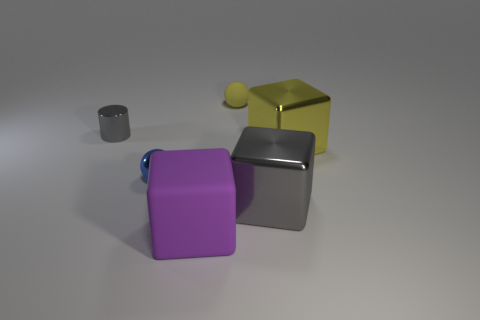Subtract all metallic cubes. How many cubes are left? 1 Subtract 1 blocks. How many blocks are left? 2 Add 3 small gray rubber cubes. How many objects exist? 9 Subtract all spheres. How many objects are left? 4 Subtract 0 gray spheres. How many objects are left? 6 Subtract all big cyan matte balls. Subtract all purple matte objects. How many objects are left? 5 Add 6 big metallic things. How many big metallic things are left? 8 Add 6 large brown cylinders. How many large brown cylinders exist? 6 